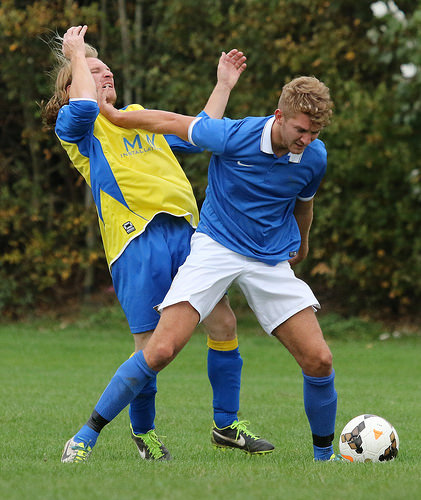<image>
Can you confirm if the ball is behind the man? No. The ball is not behind the man. From this viewpoint, the ball appears to be positioned elsewhere in the scene. 